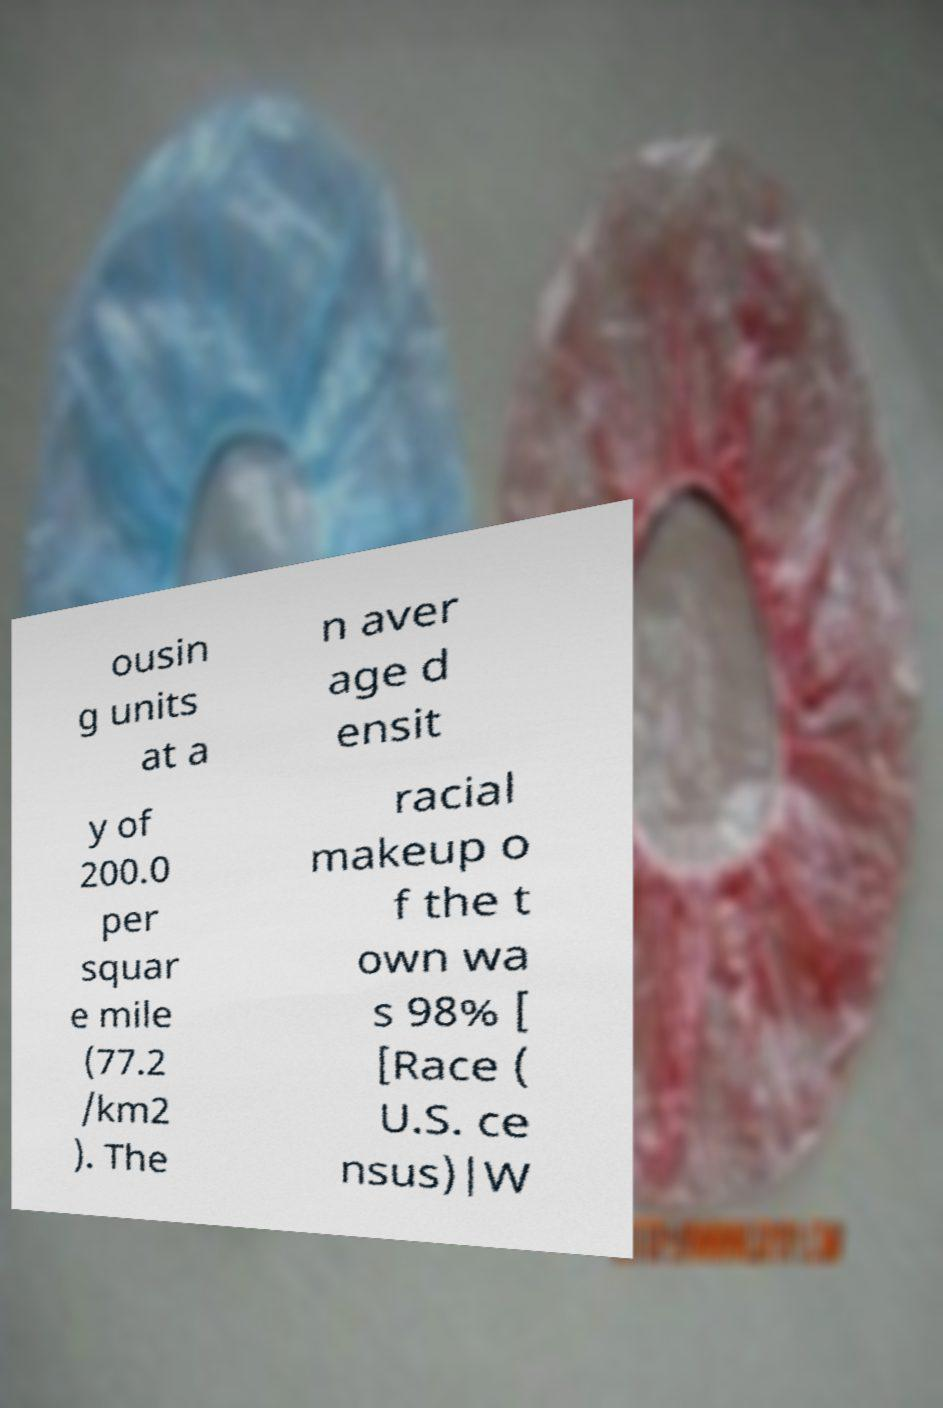Can you accurately transcribe the text from the provided image for me? ousin g units at a n aver age d ensit y of 200.0 per squar e mile (77.2 /km2 ). The racial makeup o f the t own wa s 98% [ [Race ( U.S. ce nsus)|W 